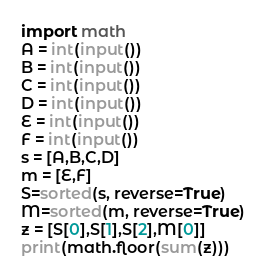<code> <loc_0><loc_0><loc_500><loc_500><_Python_>import math
A = int(input())
B = int(input())
C = int(input())
D = int(input())
E = int(input())
F = int(input())
s = [A,B,C,D]
m = [E,F]
S=sorted(s, reverse=True)
M=sorted(m, reverse=True)
z = [S[0],S[1],S[2],M[0]]
print(math.floor(sum(z)))
</code> 